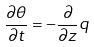<formula> <loc_0><loc_0><loc_500><loc_500>\frac { \partial \theta } { \partial t } = - \frac { \partial } { \partial z } q</formula> 